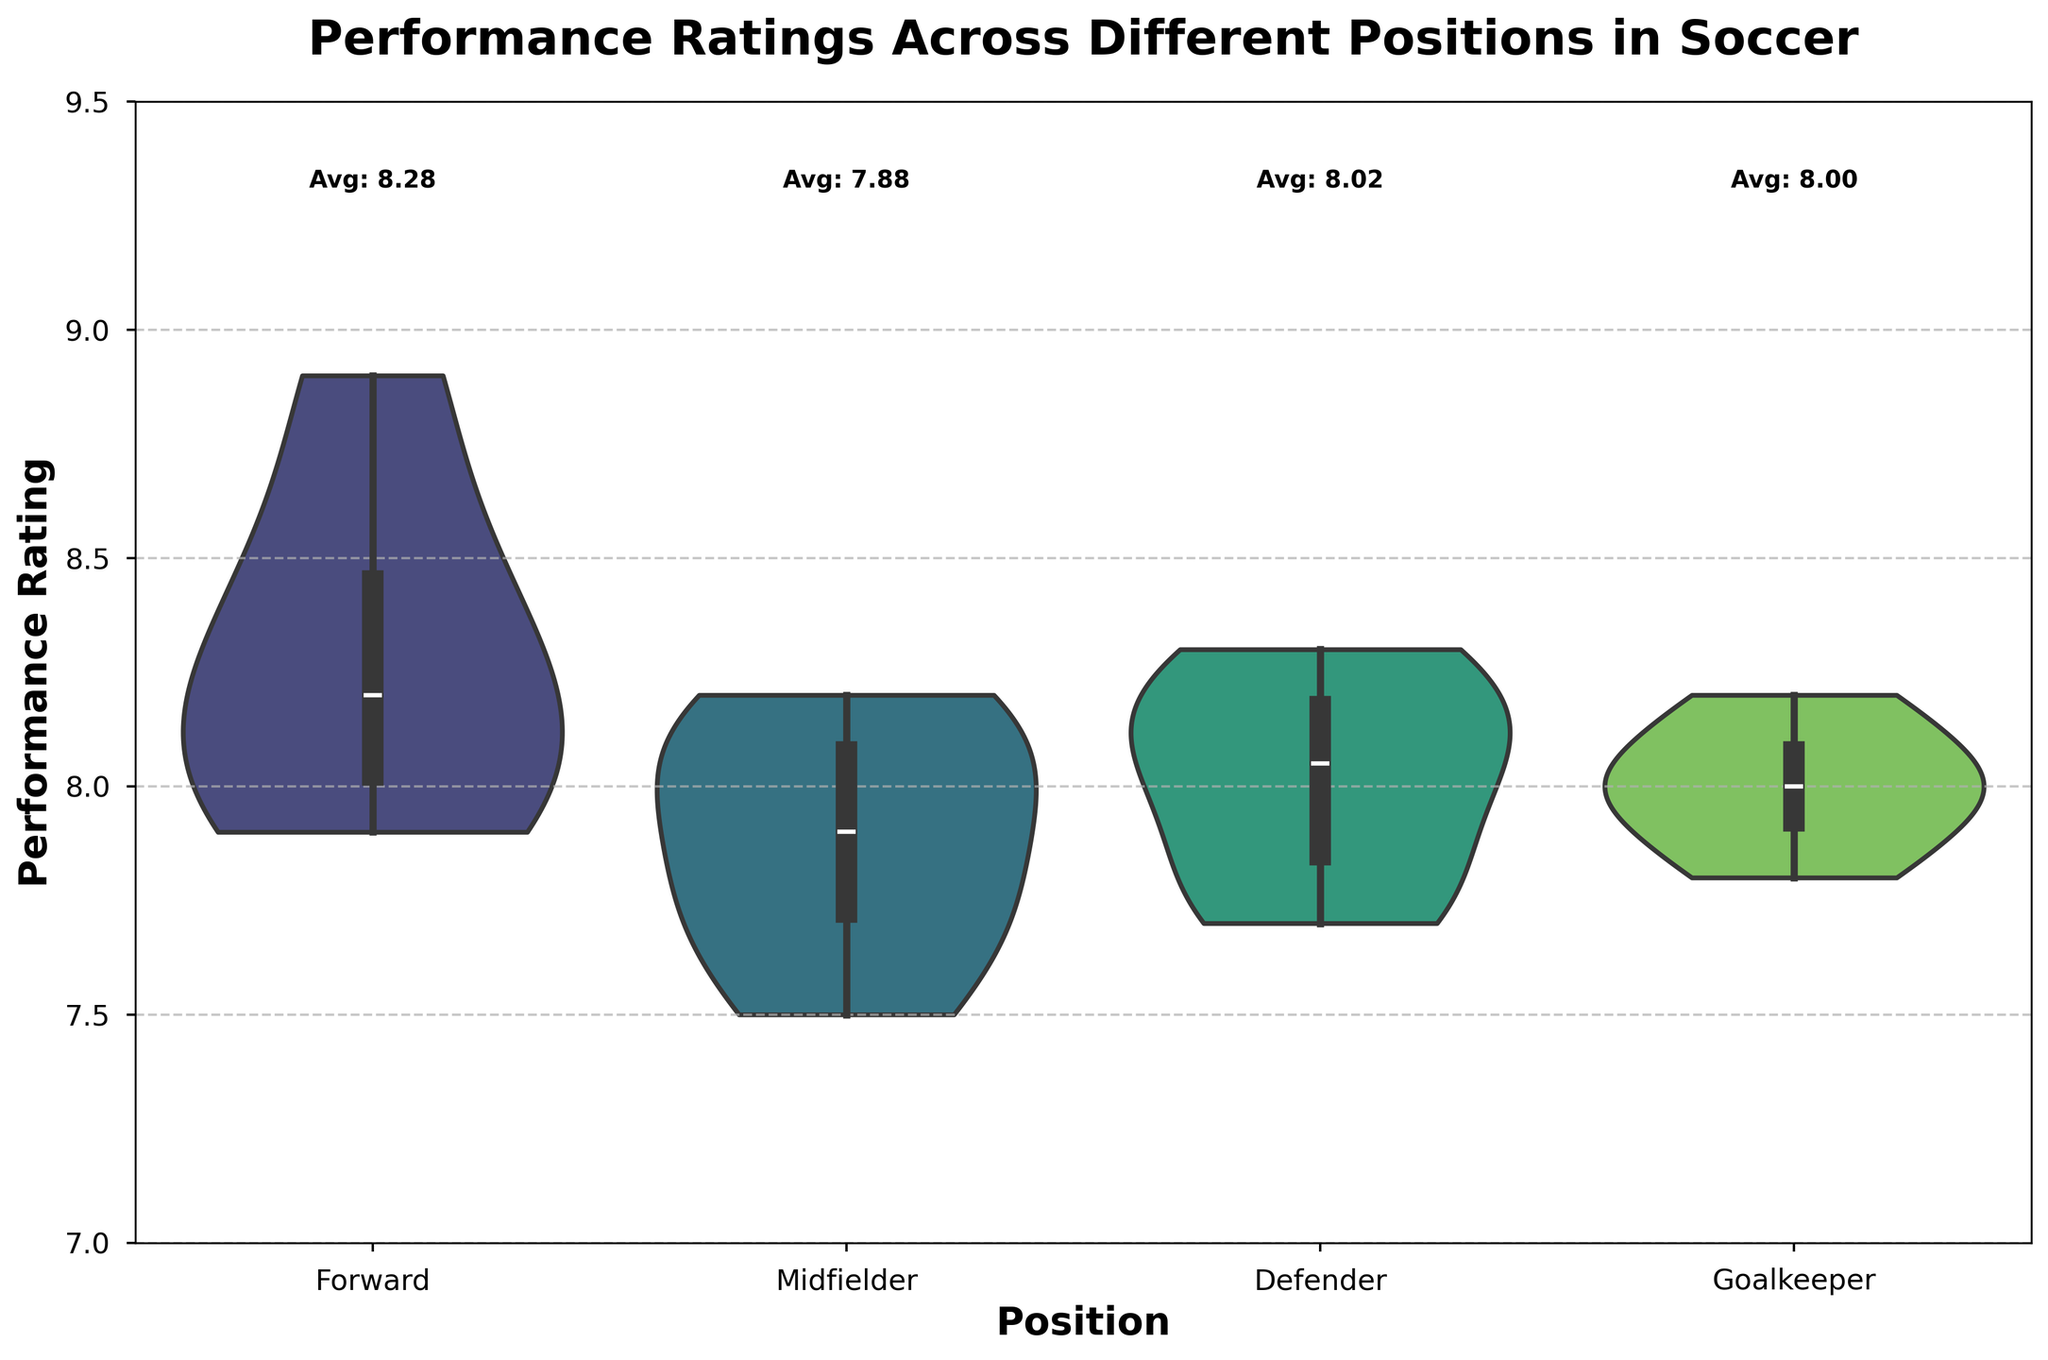what is the title of the plot? The title is the text at the top of the plot. It summarizes the content of the chart in one sentence. The title reads "Performance Ratings Across Different Positions in Soccer".
Answer: Performance Ratings Across Different Positions in Soccer what positions are shown on the x-axis? Look at the x-axis labels to see which positions are indicated. The positions shown are Forward, Midfielder, Defender, and Goalkeeper.
Answer: Forward, Midfielder, Defender, Goalkeeper what color palette is used in the violin chart? The color palette refers to the set of colors used to fill the violin plots. The color palette used is 'viridis', which ranges from dark green to yellow and purple.
Answer: viridis what is the average performance rating for defenders? Look above the "Defender" violin plot for the text annotation. It reads "Avg: 8.02".
Answer: 8.02 how does the spread of performance ratings for goalkeepers compare to that of midfielders? The spread can be analyzed by looking at the width of the violin plots. For Goalkeepers, the performance ratings range between about 7.8 and 8.2. For Midfielders, the range is from about 7.5 to 8.2, showing Midfielders have a slightly wider spread than Goalkeepers.
Answer: Midfielders have a wider spread which position has the highest average performance rating? Look at the text annotations above each position's violin plot. The highest average is indicated above "Forward" with "Avg: 8.28".
Answer: Forward is the average performance rating for midfielders closer to that of defenders or forwards? Compare the averages above each position's violin plot. Midfielders have an average of 7.88, Defenders - 8.02, and Forwards - 8.28. The average for Midfielders is closer to that of Defenders.
Answer: Defenders which position demonstrates the narrowest distribution of performance ratings? Look at the width of the violin plots. The narrowest violin plot indicates the least spread in the data. Goalkeepers have the narrowest distribution ranging approximately from 7.8 to 8.2.
Answer: Goalkeepers 